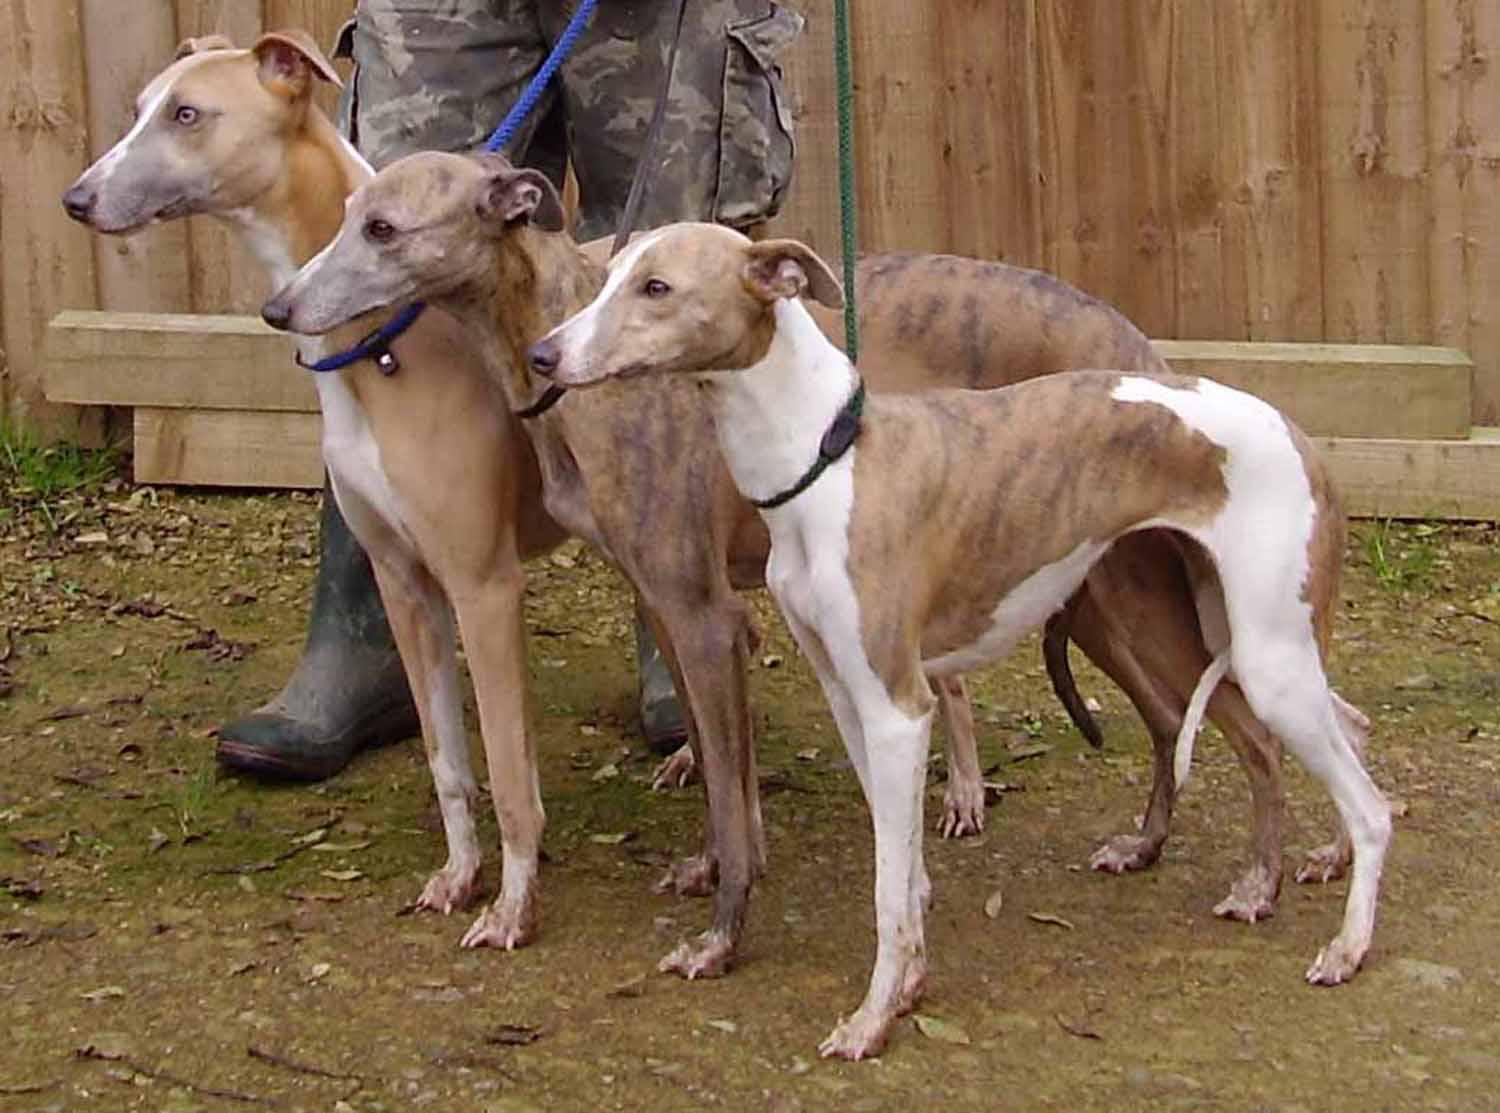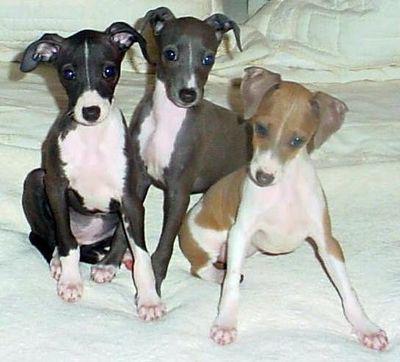The first image is the image on the left, the second image is the image on the right. Evaluate the accuracy of this statement regarding the images: "There is exactly three dogs in the right image.". Is it true? Answer yes or no. Yes. 